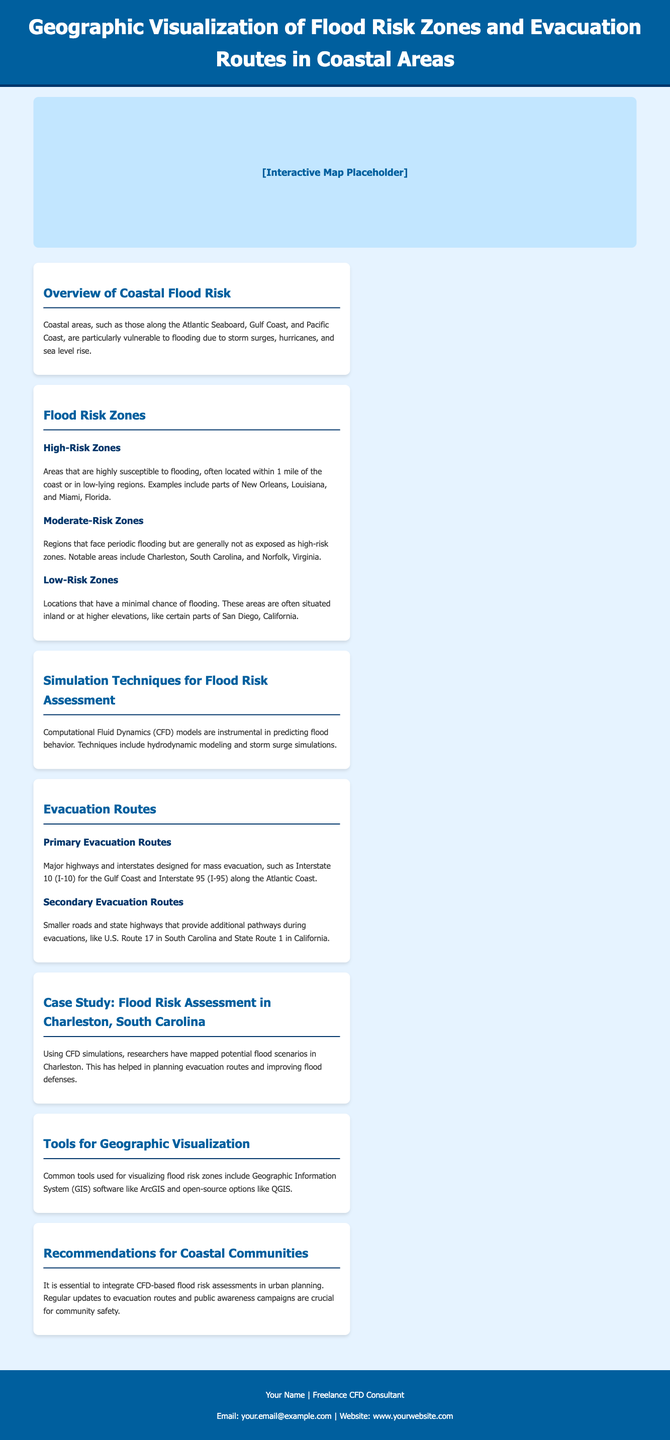What are the three types of flood risk zones mentioned? The document lists three types of flood risk zones: High-Risk Zones, Moderate-Risk Zones, and Low-Risk Zones.
Answer: High-Risk Zones, Moderate-Risk Zones, Low-Risk Zones Which coastal area is highlighted as a high-risk zone example? The document provides examples of high-risk zones, specifically naming New Orleans, Louisiana, and Miami, Florida.
Answer: New Orleans, Louisiana What major highway is designated as a primary evacuation route for the Gulf Coast? The infographic mentions Interstate 10 (I-10) as a primary evacuation route for the Gulf Coast.
Answer: Interstate 10 (I-10) What simulation technique is mentioned for flood risk assessment? The document states that Computational Fluid Dynamics (CFD) models are used for predicting flood behavior in risk assessments.
Answer: Computational Fluid Dynamics (CFD) How often should evacuation routes be updated according to the recommendations? The document emphasizes the importance of regular updates to evacuation routes as part of its recommendations.
Answer: Regularly 